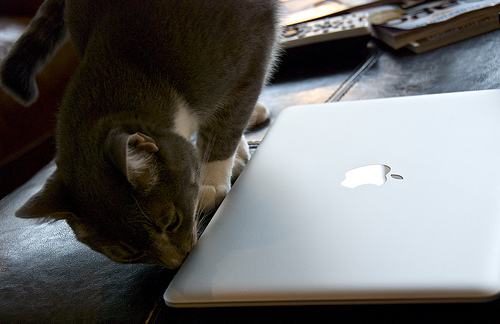How many black laptops are there? There are no black laptops visible in the image. There is only one silver-colored laptop visible, with an Apple logo on it, which suggests it is a MacBook. 